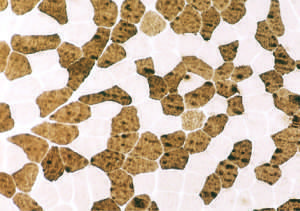did urate crystals correspond to findings in the figure?
Answer the question using a single word or phrase. No 